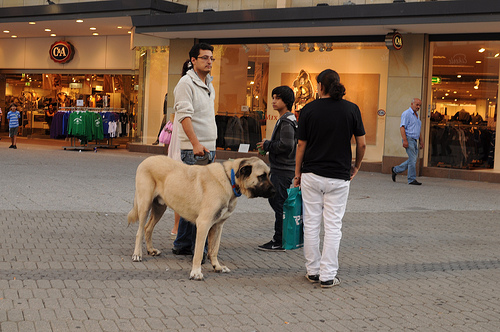What type of animal is wearing a collar? The animal wearing a collar is a dog, typically signifying ownership and responsibility by the humans. 